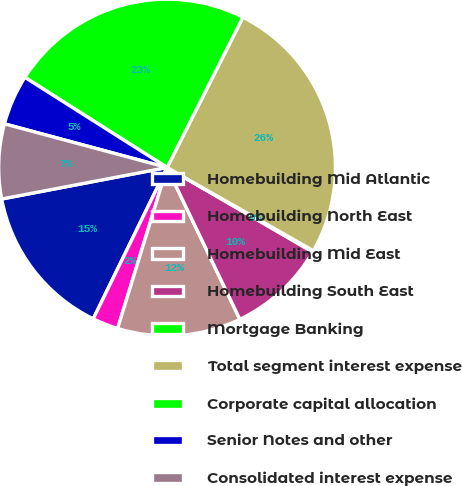Convert chart. <chart><loc_0><loc_0><loc_500><loc_500><pie_chart><fcel>Homebuilding Mid Atlantic<fcel>Homebuilding North East<fcel>Homebuilding Mid East<fcel>Homebuilding South East<fcel>Mortgage Banking<fcel>Total segment interest expense<fcel>Corporate capital allocation<fcel>Senior Notes and other<fcel>Consolidated interest expense<nl><fcel>14.78%<fcel>2.48%<fcel>11.86%<fcel>9.52%<fcel>0.13%<fcel>25.79%<fcel>23.44%<fcel>4.82%<fcel>7.17%<nl></chart> 